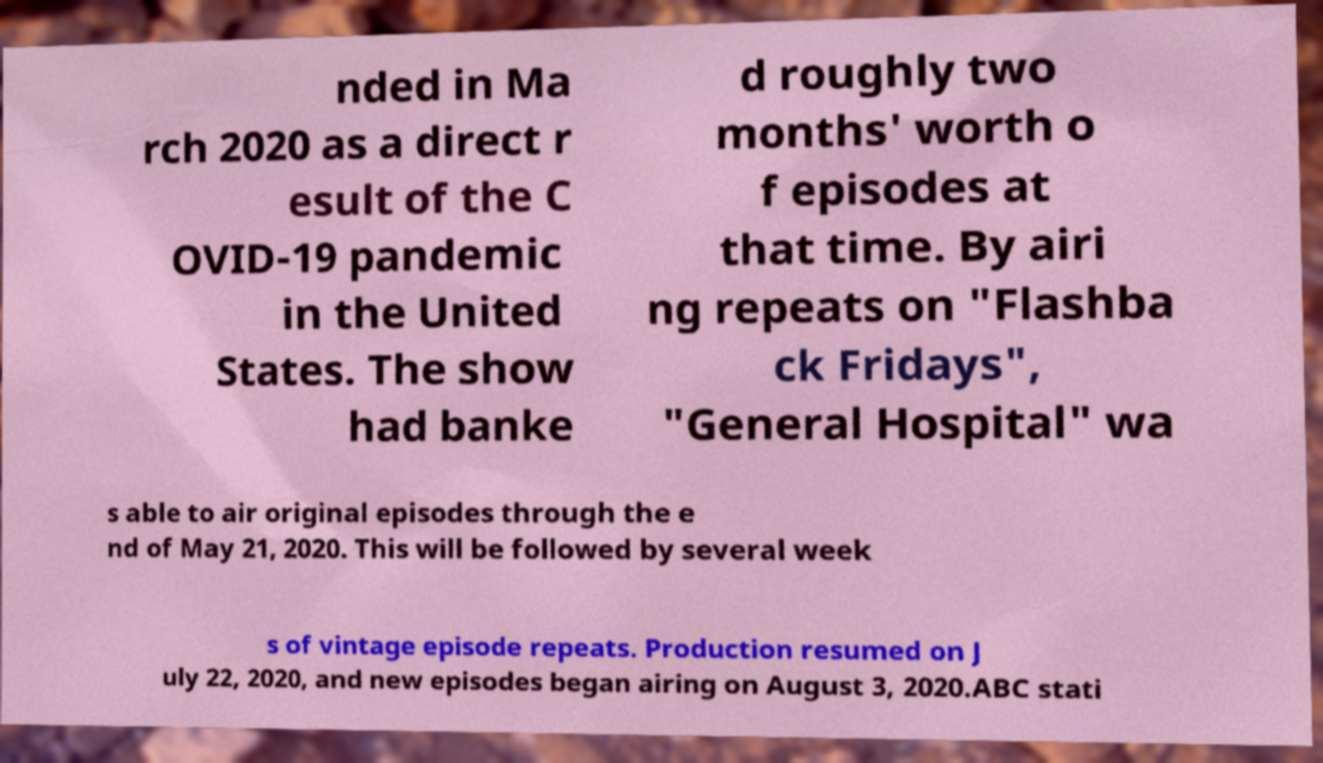Can you accurately transcribe the text from the provided image for me? nded in Ma rch 2020 as a direct r esult of the C OVID-19 pandemic in the United States. The show had banke d roughly two months' worth o f episodes at that time. By airi ng repeats on "Flashba ck Fridays", "General Hospital" wa s able to air original episodes through the e nd of May 21, 2020. This will be followed by several week s of vintage episode repeats. Production resumed on J uly 22, 2020, and new episodes began airing on August 3, 2020.ABC stati 